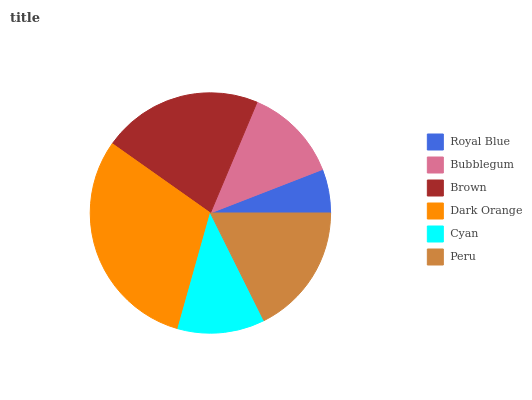Is Royal Blue the minimum?
Answer yes or no. Yes. Is Dark Orange the maximum?
Answer yes or no. Yes. Is Bubblegum the minimum?
Answer yes or no. No. Is Bubblegum the maximum?
Answer yes or no. No. Is Bubblegum greater than Royal Blue?
Answer yes or no. Yes. Is Royal Blue less than Bubblegum?
Answer yes or no. Yes. Is Royal Blue greater than Bubblegum?
Answer yes or no. No. Is Bubblegum less than Royal Blue?
Answer yes or no. No. Is Peru the high median?
Answer yes or no. Yes. Is Bubblegum the low median?
Answer yes or no. Yes. Is Dark Orange the high median?
Answer yes or no. No. Is Dark Orange the low median?
Answer yes or no. No. 